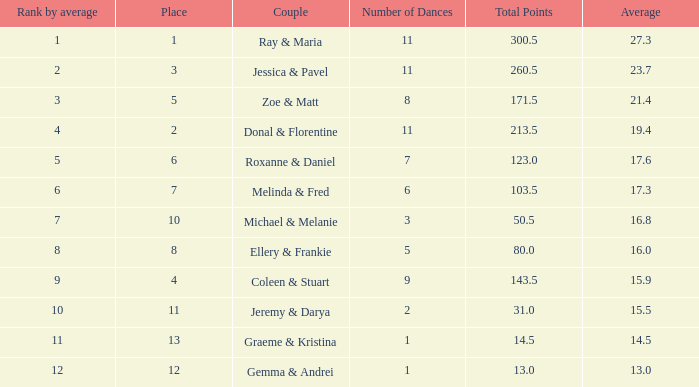If the combined points amount to 5 1.0. 